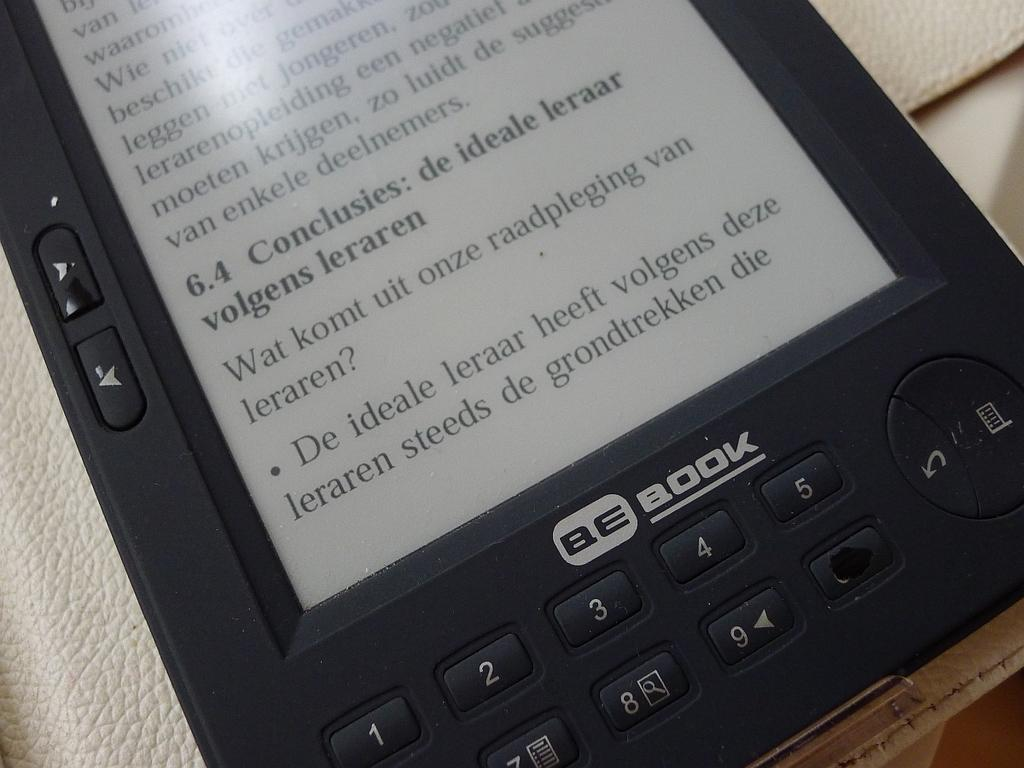<image>
Give a short and clear explanation of the subsequent image. A tablet that is displaying a foreign language and BE Book on it. 